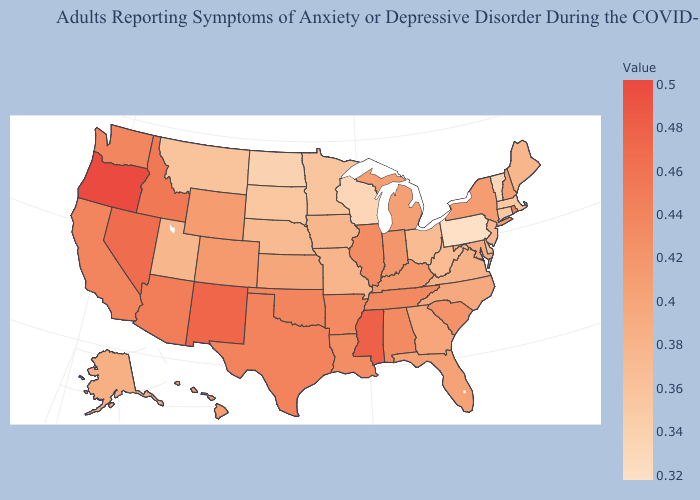Which states have the lowest value in the USA?
Short answer required. Pennsylvania. Is the legend a continuous bar?
Quick response, please. Yes. Which states have the lowest value in the Northeast?
Short answer required. Pennsylvania. Does Pennsylvania have a higher value than Oregon?
Short answer required. No. Among the states that border Maryland , which have the highest value?
Give a very brief answer. Virginia. Does Pennsylvania have the lowest value in the USA?
Quick response, please. Yes. Does Idaho have a higher value than Mississippi?
Concise answer only. No. 